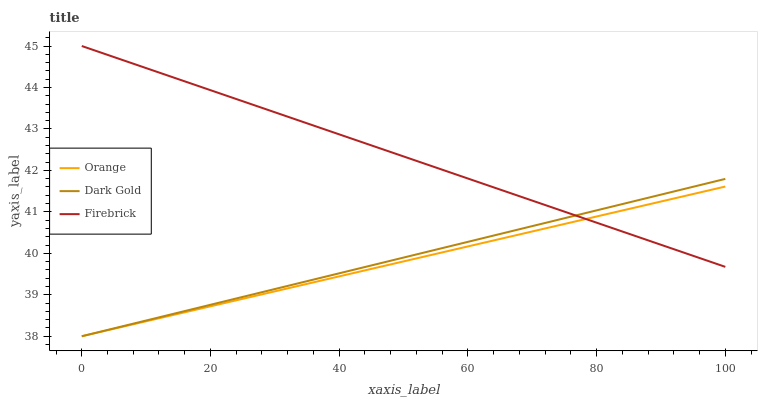Does Orange have the minimum area under the curve?
Answer yes or no. Yes. Does Firebrick have the maximum area under the curve?
Answer yes or no. Yes. Does Dark Gold have the minimum area under the curve?
Answer yes or no. No. Does Dark Gold have the maximum area under the curve?
Answer yes or no. No. Is Orange the smoothest?
Answer yes or no. Yes. Is Dark Gold the roughest?
Answer yes or no. Yes. Is Firebrick the smoothest?
Answer yes or no. No. Is Firebrick the roughest?
Answer yes or no. No. Does Orange have the lowest value?
Answer yes or no. Yes. Does Firebrick have the lowest value?
Answer yes or no. No. Does Firebrick have the highest value?
Answer yes or no. Yes. Does Dark Gold have the highest value?
Answer yes or no. No. Does Dark Gold intersect Orange?
Answer yes or no. Yes. Is Dark Gold less than Orange?
Answer yes or no. No. Is Dark Gold greater than Orange?
Answer yes or no. No. 